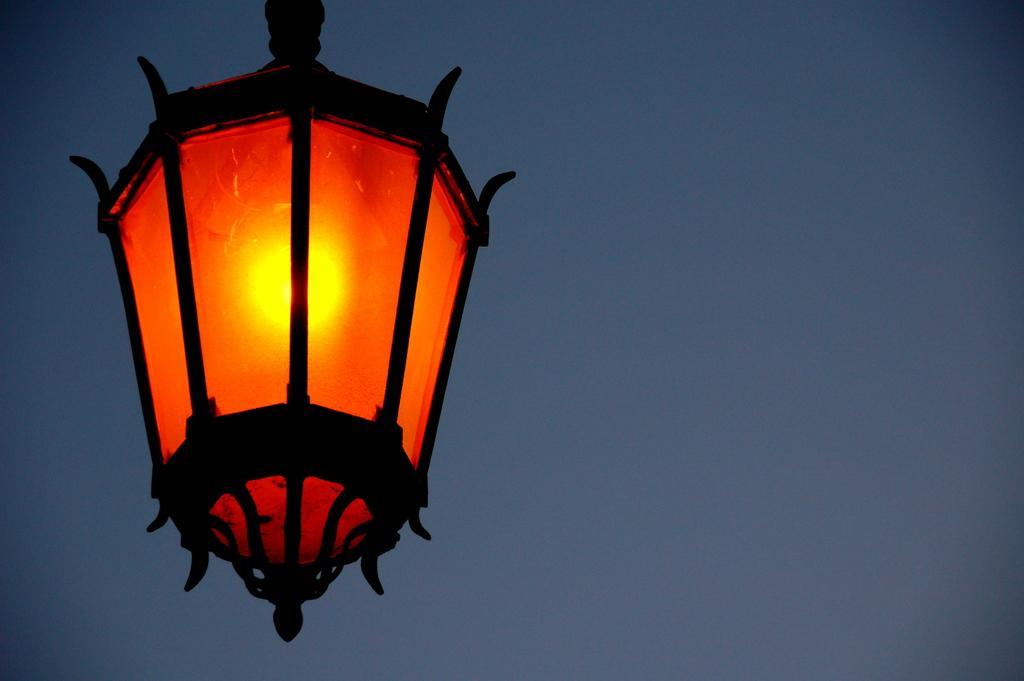Describe this image in one or two sentences. In the picture we can see a lamp inside it we can see the bulb which is yellow in color. 